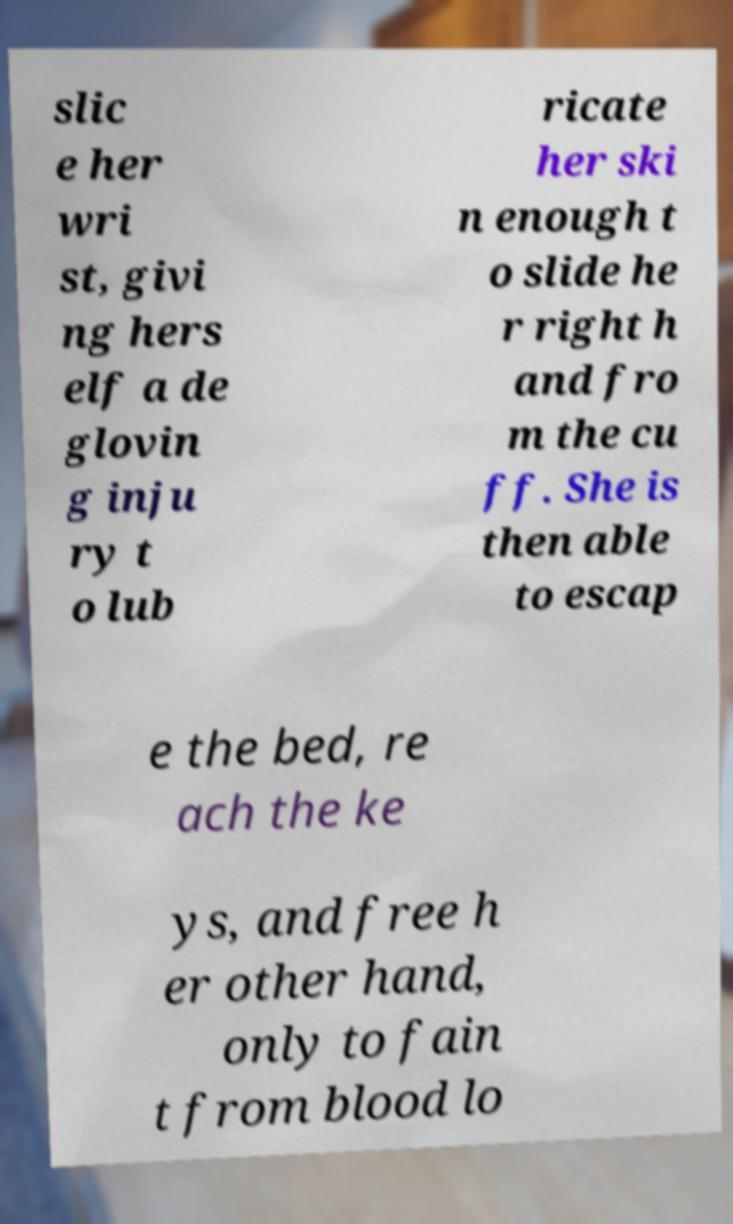Please identify and transcribe the text found in this image. slic e her wri st, givi ng hers elf a de glovin g inju ry t o lub ricate her ski n enough t o slide he r right h and fro m the cu ff. She is then able to escap e the bed, re ach the ke ys, and free h er other hand, only to fain t from blood lo 